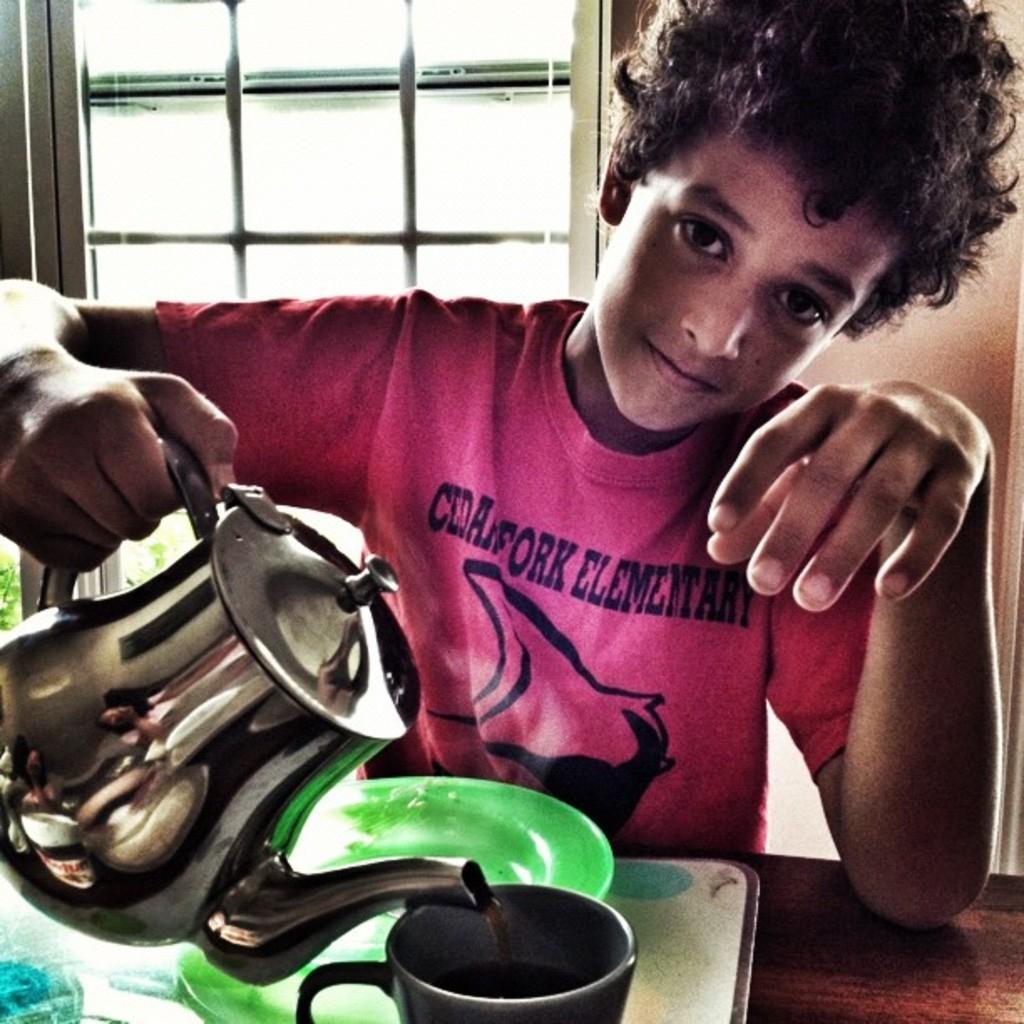Describe this image in one or two sentences. In this image we can see a boy holding a jug. In front of him there is a wooden surface. On that there is a tray with plate and cup. In the back there is a wall with window. 